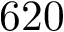<formula> <loc_0><loc_0><loc_500><loc_500>6 2 0</formula> 